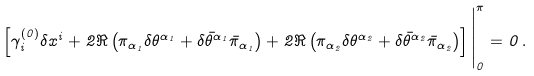<formula> <loc_0><loc_0><loc_500><loc_500>\left [ \gamma _ { i } ^ { ( 0 ) } \delta x ^ { i } + 2 \Re \left ( \pi _ { \alpha _ { 1 } } \delta \theta ^ { \alpha _ { 1 } } + \delta \bar { \theta } ^ { \alpha _ { 1 } } \bar { \pi } _ { \alpha _ { 1 } } \right ) + 2 \Re \left ( \pi _ { \alpha _ { 2 } } \delta \theta ^ { \alpha _ { 2 } } + \delta \bar { \theta } ^ { \alpha _ { 2 } } \bar { \pi } _ { \alpha _ { 2 } } \right ) \right ] \Big | _ { 0 } ^ { \pi } = 0 \, .</formula> 